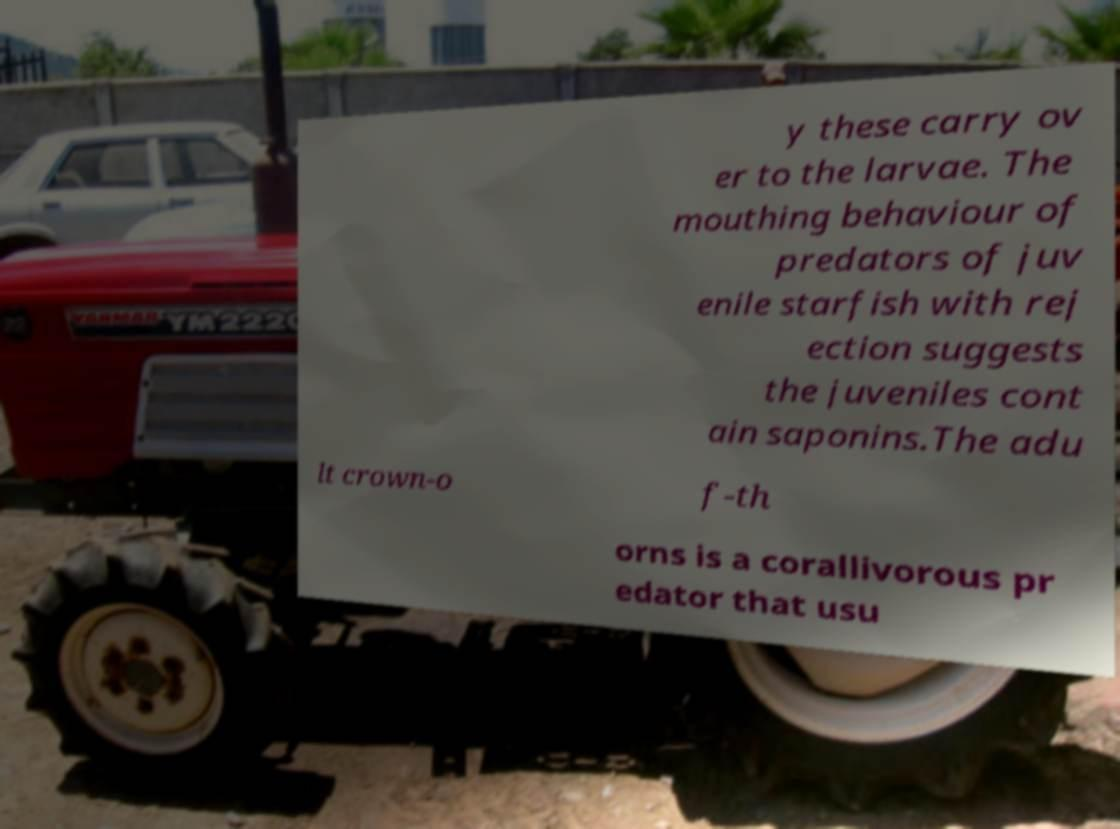Please identify and transcribe the text found in this image. y these carry ov er to the larvae. The mouthing behaviour of predators of juv enile starfish with rej ection suggests the juveniles cont ain saponins.The adu lt crown-o f-th orns is a corallivorous pr edator that usu 